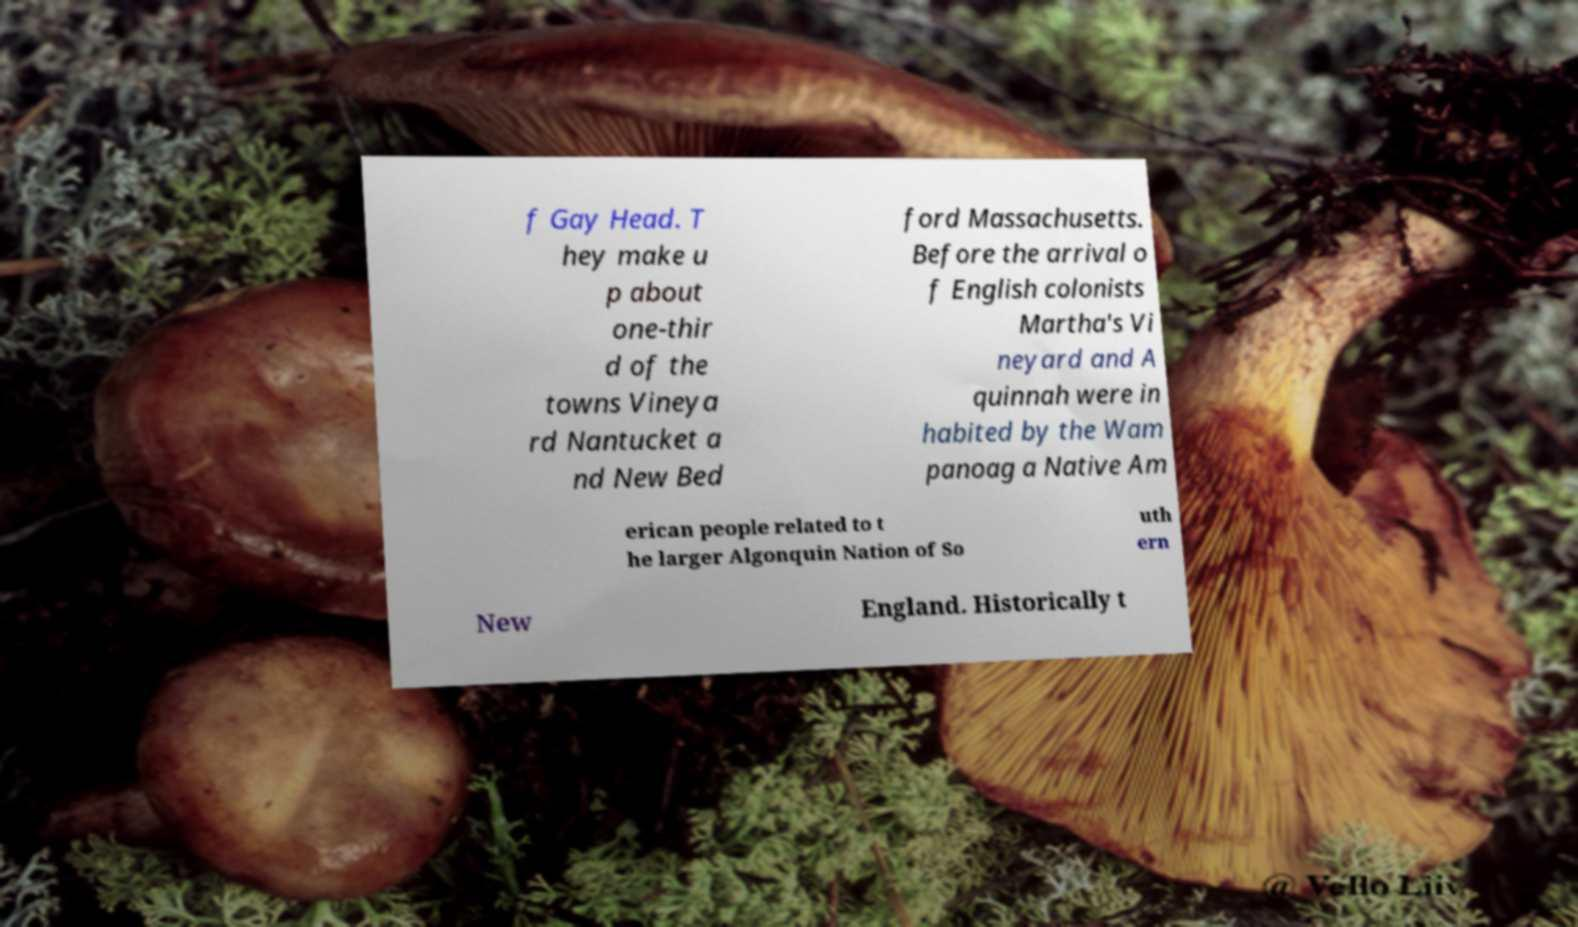Please identify and transcribe the text found in this image. f Gay Head. T hey make u p about one-thir d of the towns Vineya rd Nantucket a nd New Bed ford Massachusetts. Before the arrival o f English colonists Martha's Vi neyard and A quinnah were in habited by the Wam panoag a Native Am erican people related to t he larger Algonquin Nation of So uth ern New England. Historically t 